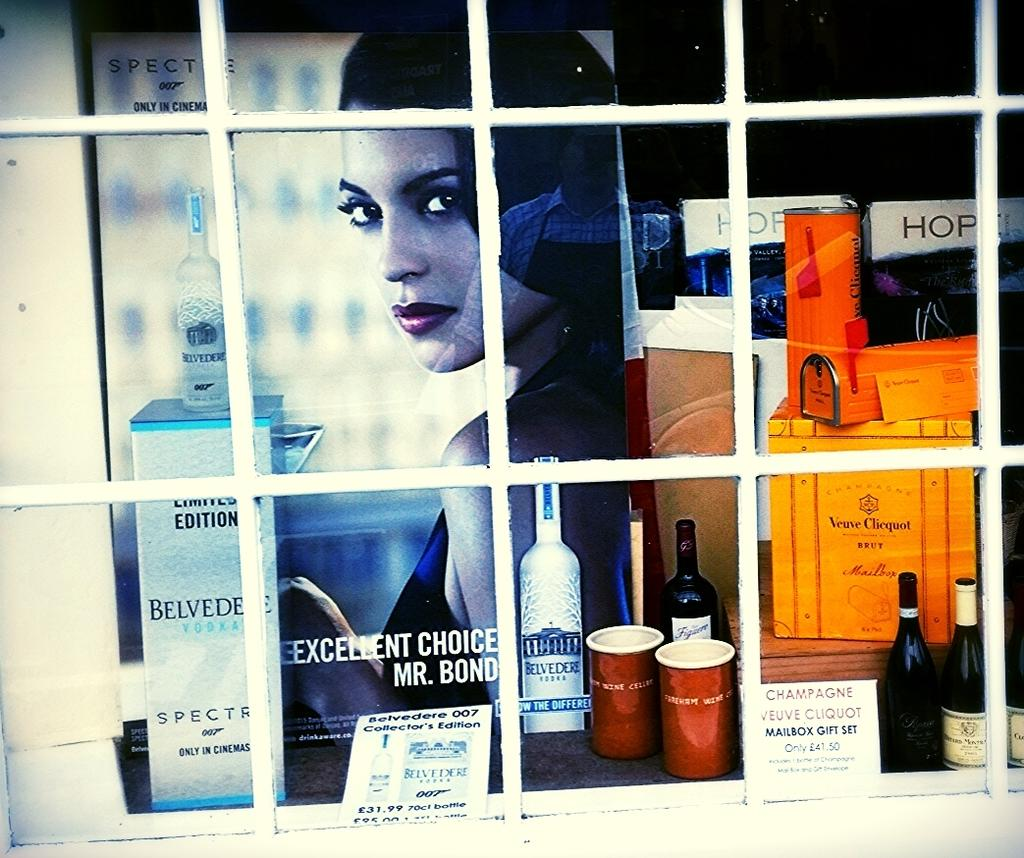What can be seen through the window in the image? A poster is visible through the window. What is depicted on the poster? The poster contains an image of a person. What else is visible behind the window? There is a group of objects behind the window. What type of needle is being used by the person in the image? There is no needle present in the image; it only contains a poster with an image of a person. 